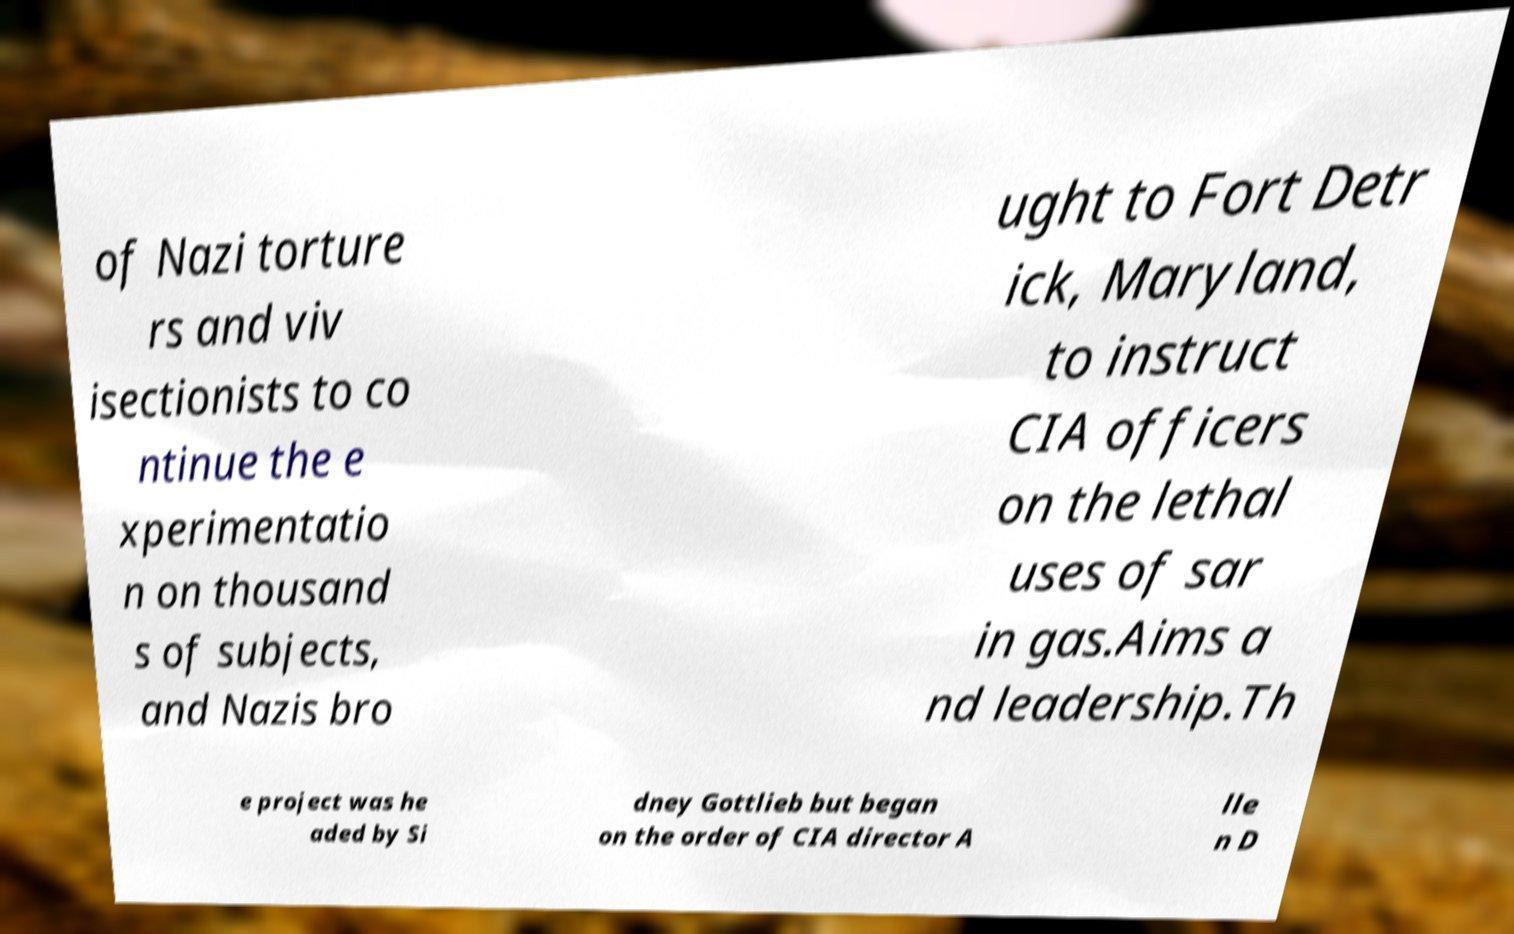Could you extract and type out the text from this image? of Nazi torture rs and viv isectionists to co ntinue the e xperimentatio n on thousand s of subjects, and Nazis bro ught to Fort Detr ick, Maryland, to instruct CIA officers on the lethal uses of sar in gas.Aims a nd leadership.Th e project was he aded by Si dney Gottlieb but began on the order of CIA director A lle n D 